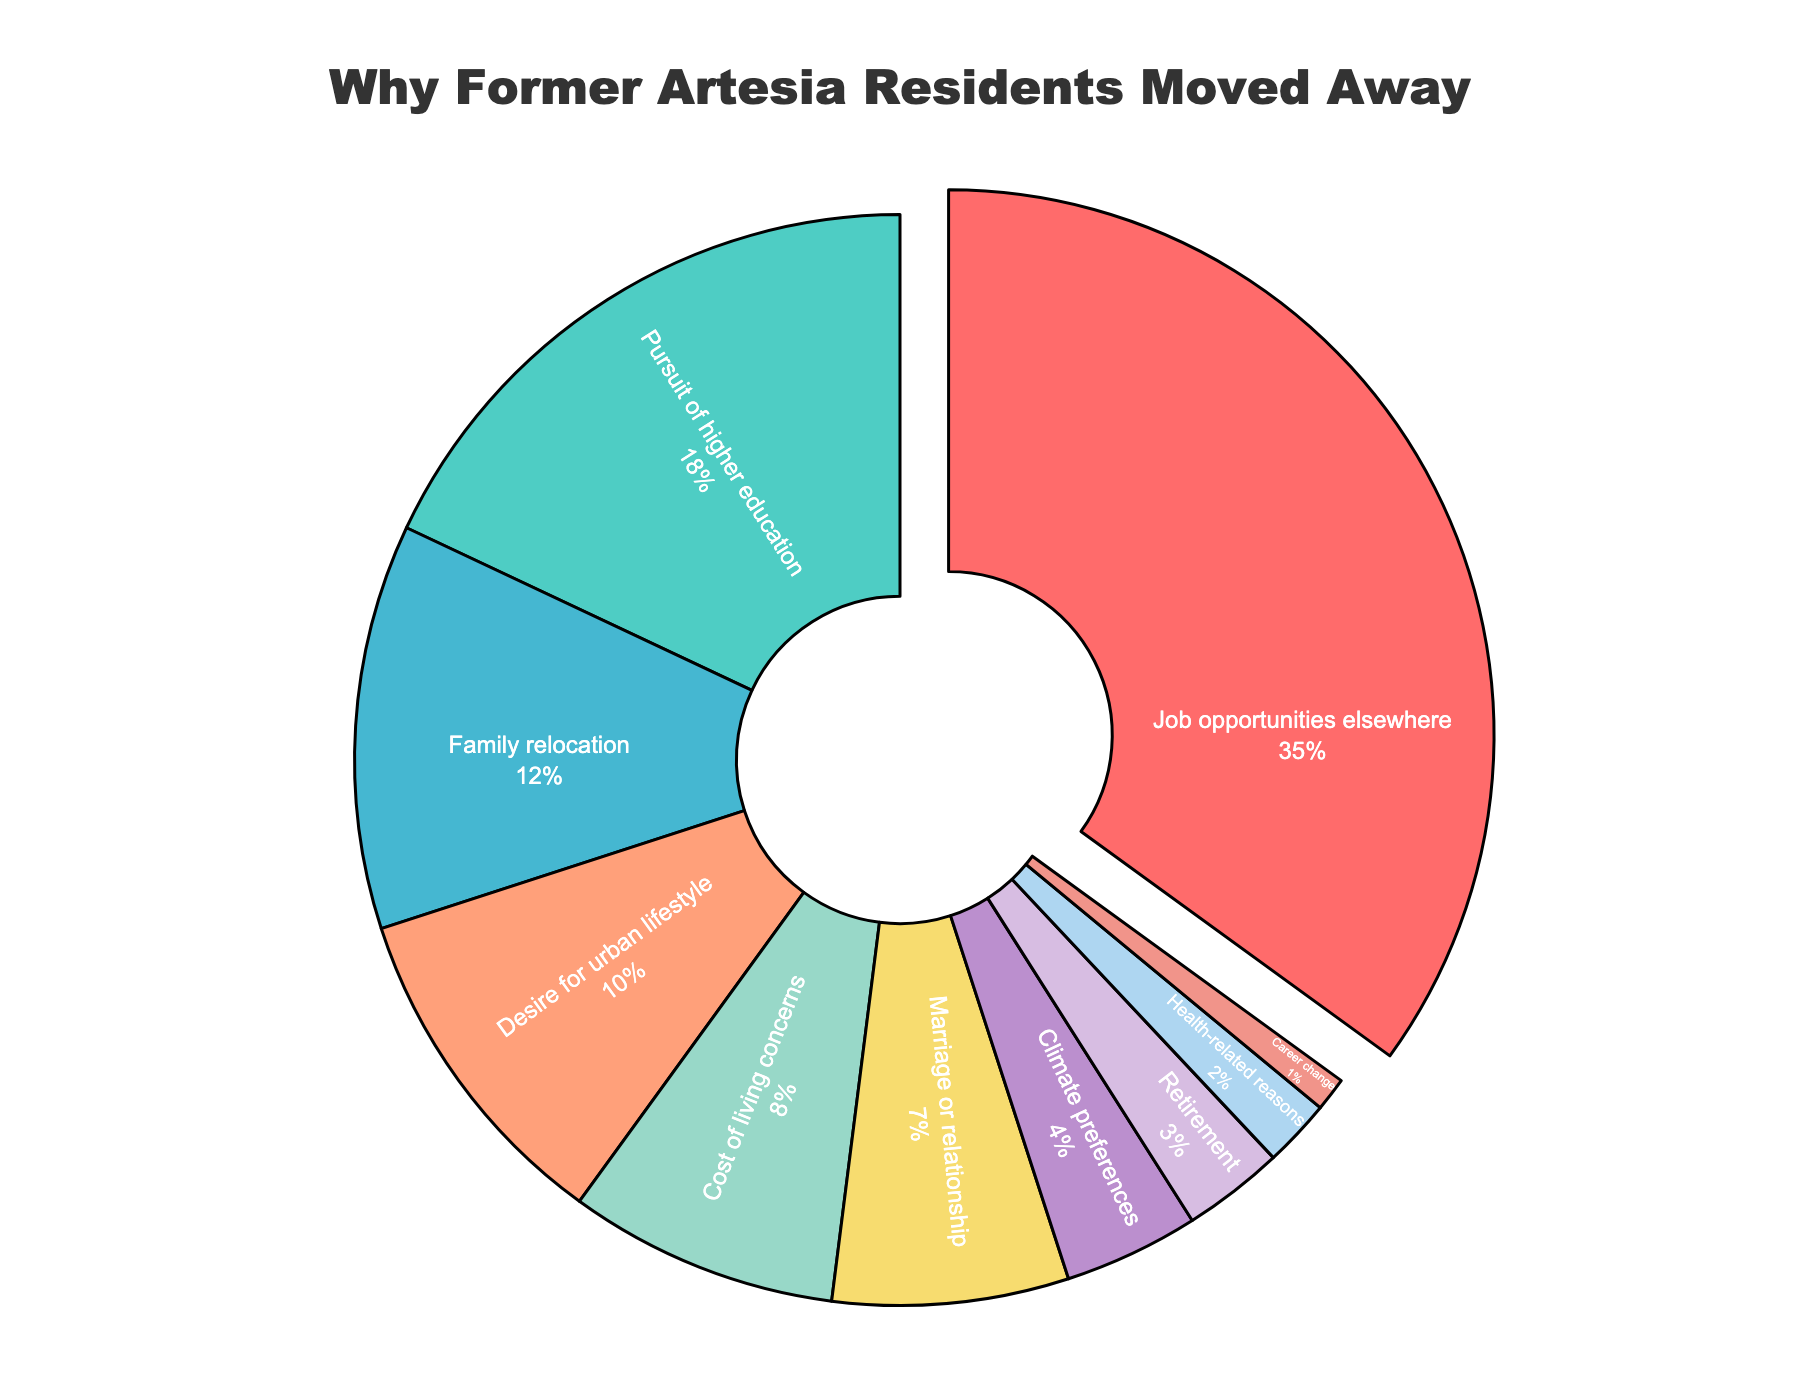What is the most common reason former Artesia residents moved away? The most common reason can be identified by finding the segment with the largest percentage. The section labeled "Job opportunities elsewhere" occupies the largest portion, 35% of the pie chart.
Answer: Job opportunities elsewhere What is the combined percentage of people moving away for family relocation and marriage or relationship? Sum the percentages for "Family relocation" (12%) and "Marriage or relationship" (7%). 12% + 7% = 19%
Answer: 19% Which reason accounts for more relocations, health-related reasons or climate preferences? Compare the slices labeled "Health-related reasons" (2%) and "Climate preferences" (4%). 4% is larger than 2%.
Answer: Climate preferences How much more likely are residents to move for job opportunities compared to retirement? Calculate the difference between "Job opportunities elsewhere" (35%) and "Retirement" (3%). 35% - 3% = 32%
Answer: 32% more likely Is higher education a more common reason for moving than cost of living concerns? Compare the slices labeled "Pursuit of higher education" (18%) and "Cost of living concerns" (8%). 18% is greater than 8%.
Answer: Yes How many times greater is the percentage of people moving for an urban lifestyle compared to a career change? Determine the ratio by dividing "Desire for urban lifestyle" (10%) by "Career change" (1%). 10% / 1% = 10 times greater
Answer: 10 times greater What percentage of residents moved for climate preferences and retirement combined? Sum the percentages for "Climate preferences" (4%) and "Retirement" (3%). 4% + 3% = 7%
Answer: 7% Which reasons have a percentage that is under 5%? Identify the segments with percentages less than 5%. "Climate preferences" (4%), "Retirement" (3%), "Health-related reasons" (2%), and "Career change" (1%).
Answer: Climate preferences, Retirement, Health-related reasons, Career change What is the difference in percentage between those moving for family relocation and those for health-related reasons? Subtract the percentage for "Health-related reasons" (2%) from "Family relocation" (12%). 12% - 2% = 10%
Answer: 10% What portion of the pie chart is taken up by reasons related to relationships (Marriage or relationship and Family relocation)? Add the percentages for "Marriage or relationship" (7%) and "Family relocation" (12%). 7% + 12% = 19%
Answer: 19% 